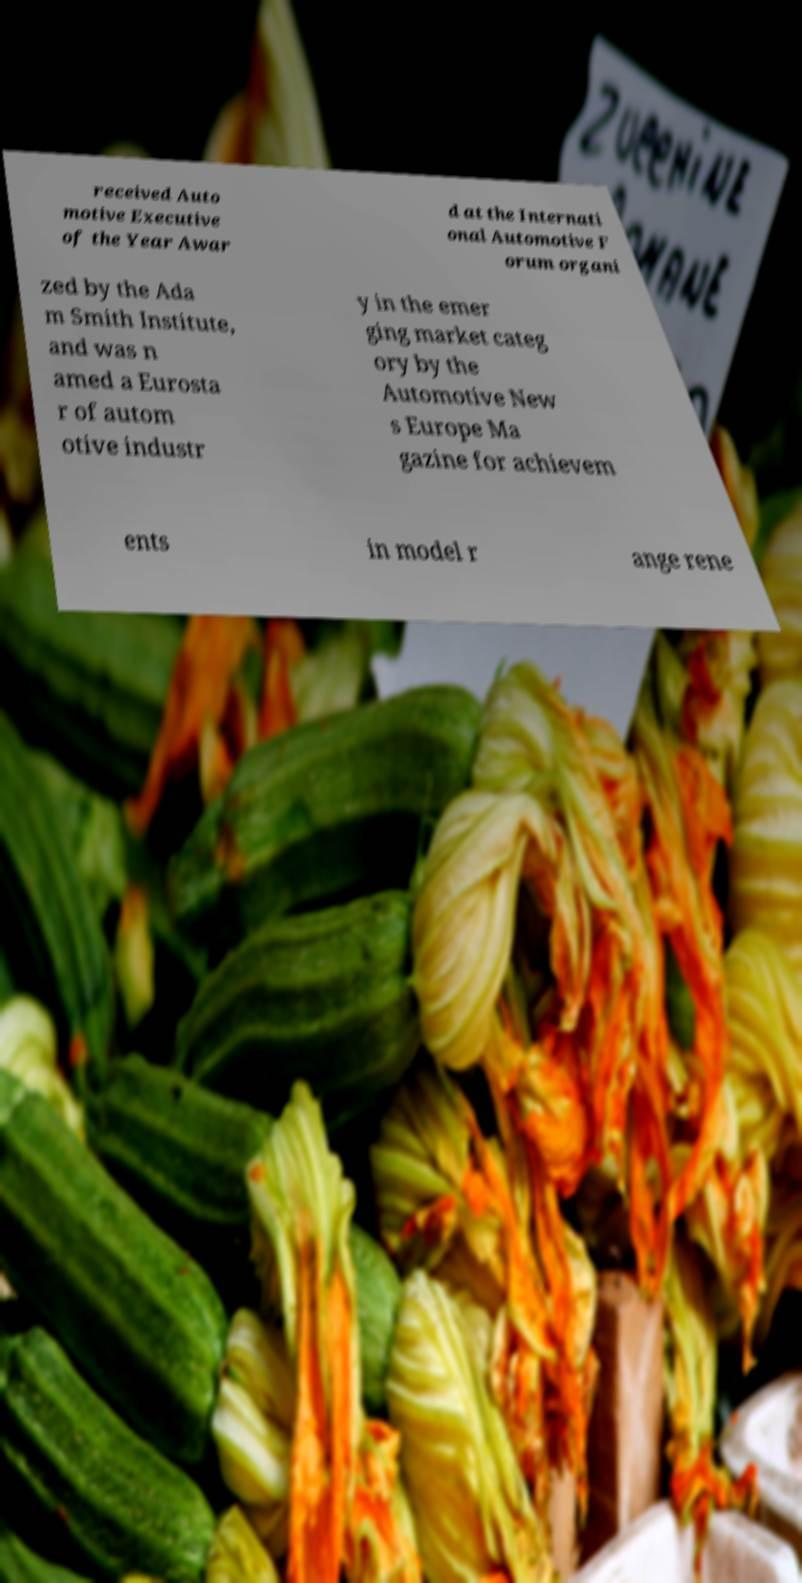For documentation purposes, I need the text within this image transcribed. Could you provide that? received Auto motive Executive of the Year Awar d at the Internati onal Automotive F orum organi zed by the Ada m Smith Institute, and was n amed a Eurosta r of autom otive industr y in the emer ging market categ ory by the Automotive New s Europe Ma gazine for achievem ents in model r ange rene 